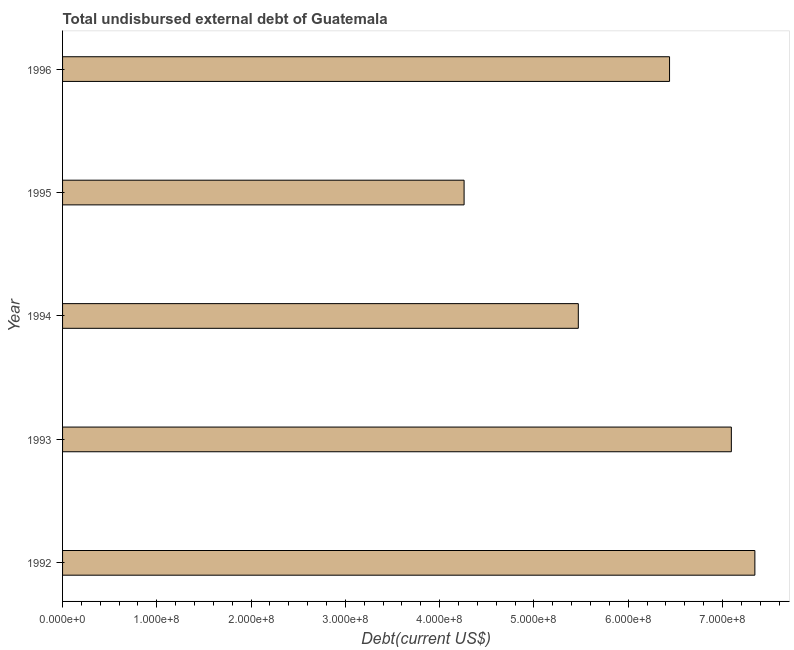Does the graph contain any zero values?
Your answer should be very brief. No. What is the title of the graph?
Your answer should be compact. Total undisbursed external debt of Guatemala. What is the label or title of the X-axis?
Ensure brevity in your answer.  Debt(current US$). What is the total debt in 1992?
Offer a terse response. 7.34e+08. Across all years, what is the maximum total debt?
Offer a very short reply. 7.34e+08. Across all years, what is the minimum total debt?
Give a very brief answer. 4.26e+08. In which year was the total debt minimum?
Keep it short and to the point. 1995. What is the sum of the total debt?
Your response must be concise. 3.06e+09. What is the difference between the total debt in 1992 and 1995?
Ensure brevity in your answer.  3.08e+08. What is the average total debt per year?
Give a very brief answer. 6.12e+08. What is the median total debt?
Offer a terse response. 6.44e+08. Do a majority of the years between 1992 and 1996 (inclusive) have total debt greater than 660000000 US$?
Keep it short and to the point. No. What is the ratio of the total debt in 1992 to that in 1996?
Make the answer very short. 1.14. Is the total debt in 1992 less than that in 1996?
Keep it short and to the point. No. Is the difference between the total debt in 1992 and 1993 greater than the difference between any two years?
Keep it short and to the point. No. What is the difference between the highest and the second highest total debt?
Keep it short and to the point. 2.50e+07. Is the sum of the total debt in 1993 and 1994 greater than the maximum total debt across all years?
Provide a short and direct response. Yes. What is the difference between the highest and the lowest total debt?
Make the answer very short. 3.08e+08. In how many years, is the total debt greater than the average total debt taken over all years?
Offer a very short reply. 3. How many bars are there?
Offer a terse response. 5. Are all the bars in the graph horizontal?
Ensure brevity in your answer.  Yes. What is the difference between two consecutive major ticks on the X-axis?
Your answer should be very brief. 1.00e+08. Are the values on the major ticks of X-axis written in scientific E-notation?
Offer a very short reply. Yes. What is the Debt(current US$) of 1992?
Keep it short and to the point. 7.34e+08. What is the Debt(current US$) in 1993?
Ensure brevity in your answer.  7.09e+08. What is the Debt(current US$) in 1994?
Give a very brief answer. 5.47e+08. What is the Debt(current US$) of 1995?
Provide a succinct answer. 4.26e+08. What is the Debt(current US$) in 1996?
Ensure brevity in your answer.  6.44e+08. What is the difference between the Debt(current US$) in 1992 and 1993?
Offer a very short reply. 2.50e+07. What is the difference between the Debt(current US$) in 1992 and 1994?
Provide a short and direct response. 1.87e+08. What is the difference between the Debt(current US$) in 1992 and 1995?
Offer a terse response. 3.08e+08. What is the difference between the Debt(current US$) in 1992 and 1996?
Ensure brevity in your answer.  9.05e+07. What is the difference between the Debt(current US$) in 1993 and 1994?
Offer a terse response. 1.62e+08. What is the difference between the Debt(current US$) in 1993 and 1995?
Give a very brief answer. 2.83e+08. What is the difference between the Debt(current US$) in 1993 and 1996?
Offer a very short reply. 6.56e+07. What is the difference between the Debt(current US$) in 1994 and 1995?
Give a very brief answer. 1.21e+08. What is the difference between the Debt(current US$) in 1994 and 1996?
Give a very brief answer. -9.68e+07. What is the difference between the Debt(current US$) in 1995 and 1996?
Provide a short and direct response. -2.18e+08. What is the ratio of the Debt(current US$) in 1992 to that in 1993?
Make the answer very short. 1.03. What is the ratio of the Debt(current US$) in 1992 to that in 1994?
Give a very brief answer. 1.34. What is the ratio of the Debt(current US$) in 1992 to that in 1995?
Your answer should be compact. 1.72. What is the ratio of the Debt(current US$) in 1992 to that in 1996?
Your response must be concise. 1.14. What is the ratio of the Debt(current US$) in 1993 to that in 1994?
Ensure brevity in your answer.  1.3. What is the ratio of the Debt(current US$) in 1993 to that in 1995?
Keep it short and to the point. 1.67. What is the ratio of the Debt(current US$) in 1993 to that in 1996?
Offer a very short reply. 1.1. What is the ratio of the Debt(current US$) in 1994 to that in 1995?
Provide a short and direct response. 1.28. What is the ratio of the Debt(current US$) in 1995 to that in 1996?
Offer a very short reply. 0.66. 